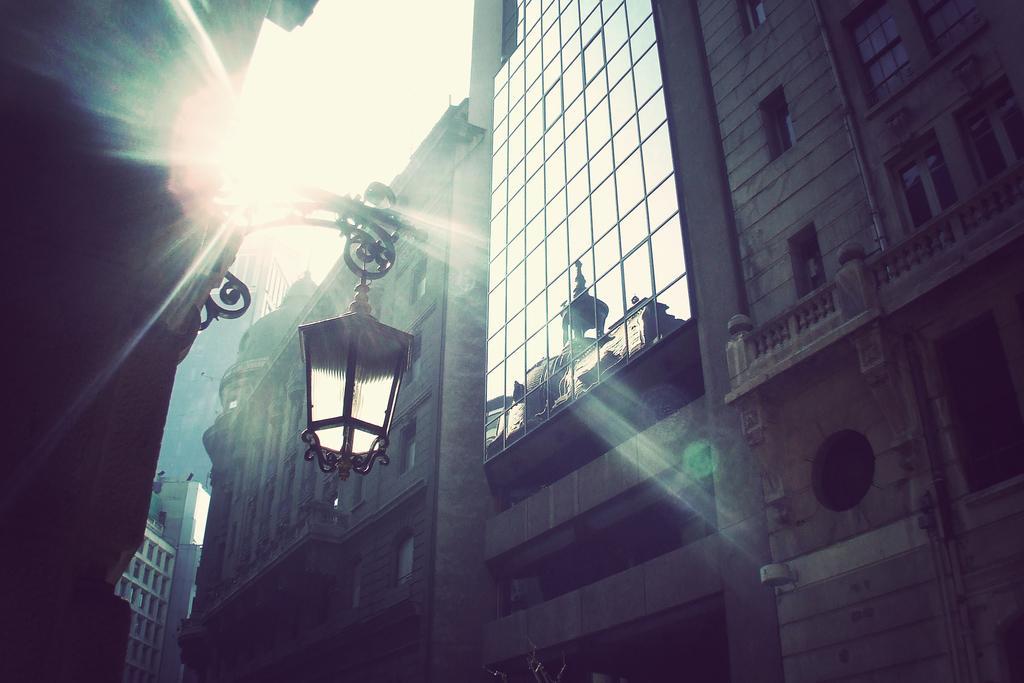Can you describe this image briefly? In this picture I can see buildings, light, and in the background there is the sky. 